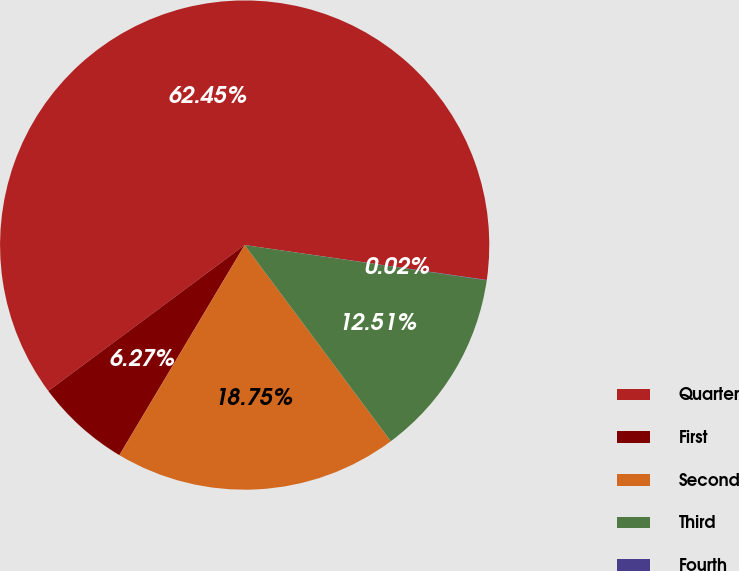Convert chart. <chart><loc_0><loc_0><loc_500><loc_500><pie_chart><fcel>Quarter<fcel>First<fcel>Second<fcel>Third<fcel>Fourth<nl><fcel>62.45%<fcel>6.27%<fcel>18.75%<fcel>12.51%<fcel>0.02%<nl></chart> 